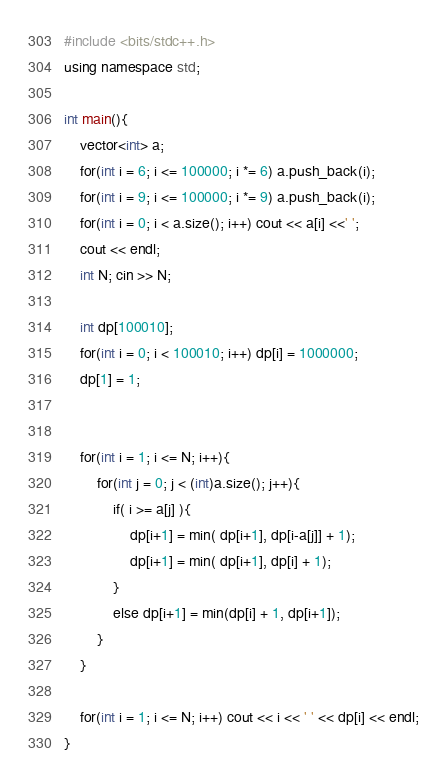<code> <loc_0><loc_0><loc_500><loc_500><_C++_>#include <bits/stdc++.h>
using namespace std;

int main(){
    vector<int> a;
    for(int i = 6; i <= 100000; i *= 6) a.push_back(i);
    for(int i = 9; i <= 100000; i *= 9) a.push_back(i);    
    for(int i = 0; i < a.size(); i++) cout << a[i] <<' ';
    cout << endl;
    int N; cin >> N;

    int dp[100010];
    for(int i = 0; i < 100010; i++) dp[i] = 1000000;
    dp[1] = 1;

    
    for(int i = 1; i <= N; i++){
        for(int j = 0; j < (int)a.size(); j++){
            if( i >= a[j] ){
                dp[i+1] = min( dp[i+1], dp[i-a[j]] + 1);
                dp[i+1] = min( dp[i+1], dp[i] + 1);
            }
            else dp[i+1] = min(dp[i] + 1, dp[i+1]);
        }
    }

    for(int i = 1; i <= N; i++) cout << i << ' ' << dp[i] << endl;
}</code> 